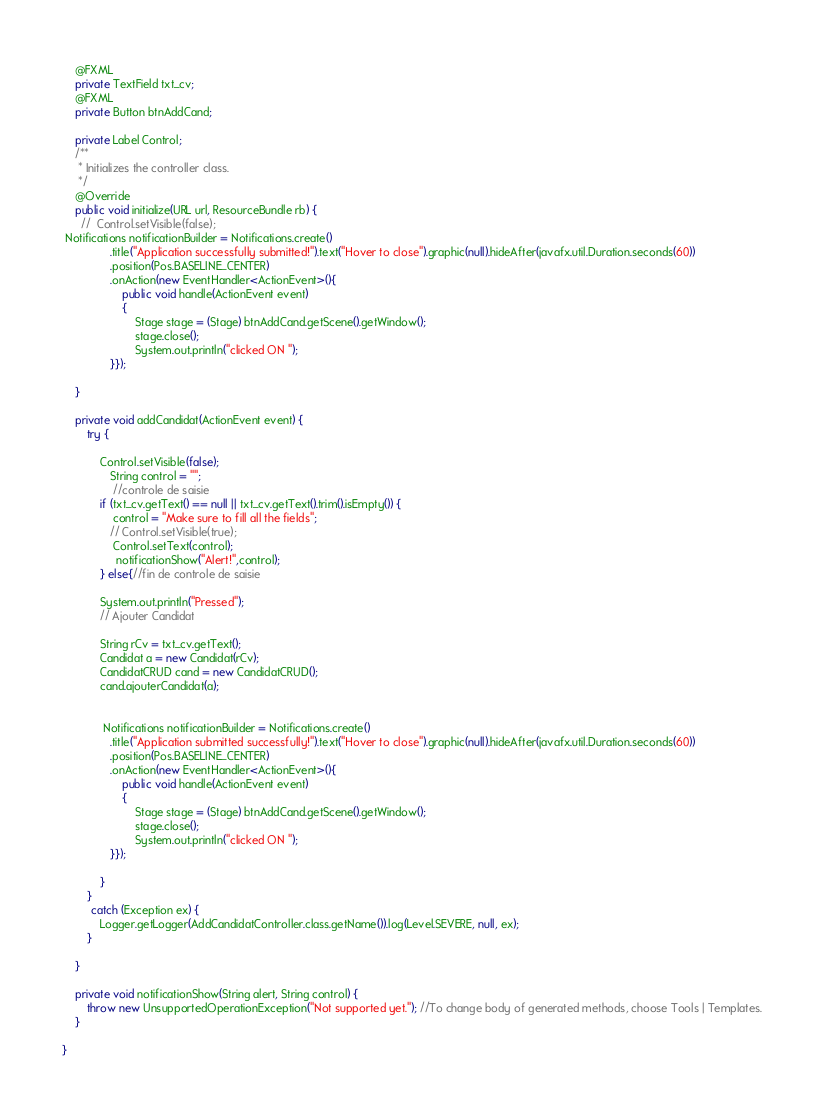<code> <loc_0><loc_0><loc_500><loc_500><_Java_>    @FXML
    private TextField txt_cv;
    @FXML
    private Button btnAddCand;

    private Label Control;
    /**
     * Initializes the controller class.
     */
    @Override
    public void initialize(URL url, ResourceBundle rb) {
      //  Control.setVisible(false);
 Notifications notificationBuilder = Notifications.create()
               .title("Application successfully submitted!").text("Hover to close").graphic(null).hideAfter(javafx.util.Duration.seconds(60))
               .position(Pos.BASELINE_CENTER)
               .onAction(new EventHandler<ActionEvent>(){
                   public void handle(ActionEvent event)
                   {
                       Stage stage = (Stage) btnAddCand.getScene().getWindow();
                       stage.close();
                       System.out.println("clicked ON ");
               }});

    }

    private void addCandidat(ActionEvent event) {
        try {
            
            Control.setVisible(false);
               String control = "";
                //controle de saisie
            if (txt_cv.getText() == null || txt_cv.getText().trim().isEmpty()) {
                control = "Make sure to fill all the fields";
               // Control.setVisible(true);
                Control.setText(control);  
                 notificationShow("Alert!",control);
            } else{//fin de controle de saisie
           
            System.out.println("Pressed");
            // Ajouter Candidat
            
            String rCv = txt_cv.getText();
            Candidat a = new Candidat(rCv);
            CandidatCRUD cand = new CandidatCRUD();
            cand.ajouterCandidat(a);
            
            
             Notifications notificationBuilder = Notifications.create()
               .title("Application submitted successfully!").text("Hover to close").graphic(null).hideAfter(javafx.util.Duration.seconds(60))
               .position(Pos.BASELINE_CENTER)
               .onAction(new EventHandler<ActionEvent>(){
                   public void handle(ActionEvent event)
                   {
                       Stage stage = (Stage) btnAddCand.getScene().getWindow();
                       stage.close();
                       System.out.println("clicked ON ");
               }});
           
            }
        }
         catch (Exception ex) {
            Logger.getLogger(AddCandidatController.class.getName()).log(Level.SEVERE, null, ex);
        }

    }

    private void notificationShow(String alert, String control) {
        throw new UnsupportedOperationException("Not supported yet."); //To change body of generated methods, choose Tools | Templates.
    }

}
</code> 